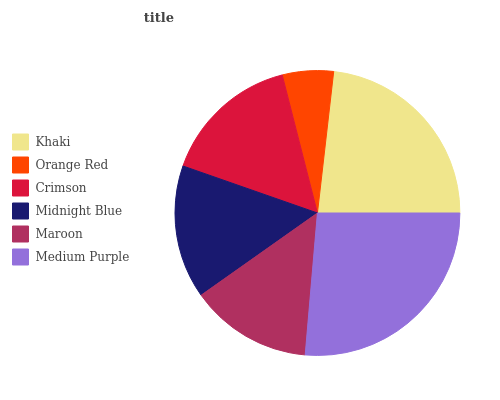Is Orange Red the minimum?
Answer yes or no. Yes. Is Medium Purple the maximum?
Answer yes or no. Yes. Is Crimson the minimum?
Answer yes or no. No. Is Crimson the maximum?
Answer yes or no. No. Is Crimson greater than Orange Red?
Answer yes or no. Yes. Is Orange Red less than Crimson?
Answer yes or no. Yes. Is Orange Red greater than Crimson?
Answer yes or no. No. Is Crimson less than Orange Red?
Answer yes or no. No. Is Crimson the high median?
Answer yes or no. Yes. Is Midnight Blue the low median?
Answer yes or no. Yes. Is Maroon the high median?
Answer yes or no. No. Is Orange Red the low median?
Answer yes or no. No. 